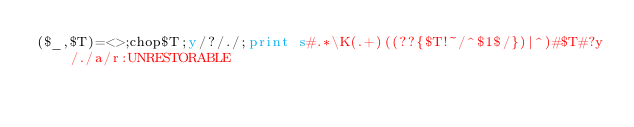<code> <loc_0><loc_0><loc_500><loc_500><_Perl_>($_,$T)=<>;chop$T;y/?/./;print s#.*\K(.+)((??{$T!~/^$1$/})|^)#$T#?y/./a/r:UNRESTORABLE</code> 